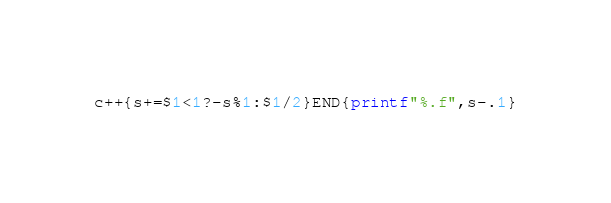<code> <loc_0><loc_0><loc_500><loc_500><_Awk_>c++{s+=$1<1?-s%1:$1/2}END{printf"%.f",s-.1}</code> 